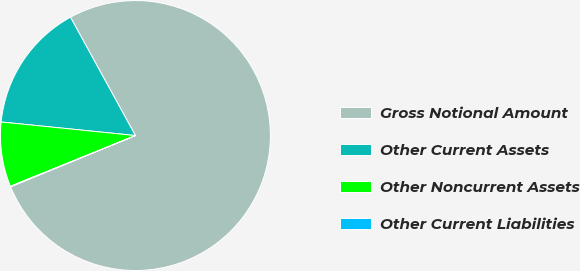<chart> <loc_0><loc_0><loc_500><loc_500><pie_chart><fcel>Gross Notional Amount<fcel>Other Current Assets<fcel>Other Noncurrent Assets<fcel>Other Current Liabilities<nl><fcel>76.79%<fcel>15.41%<fcel>7.74%<fcel>0.06%<nl></chart> 